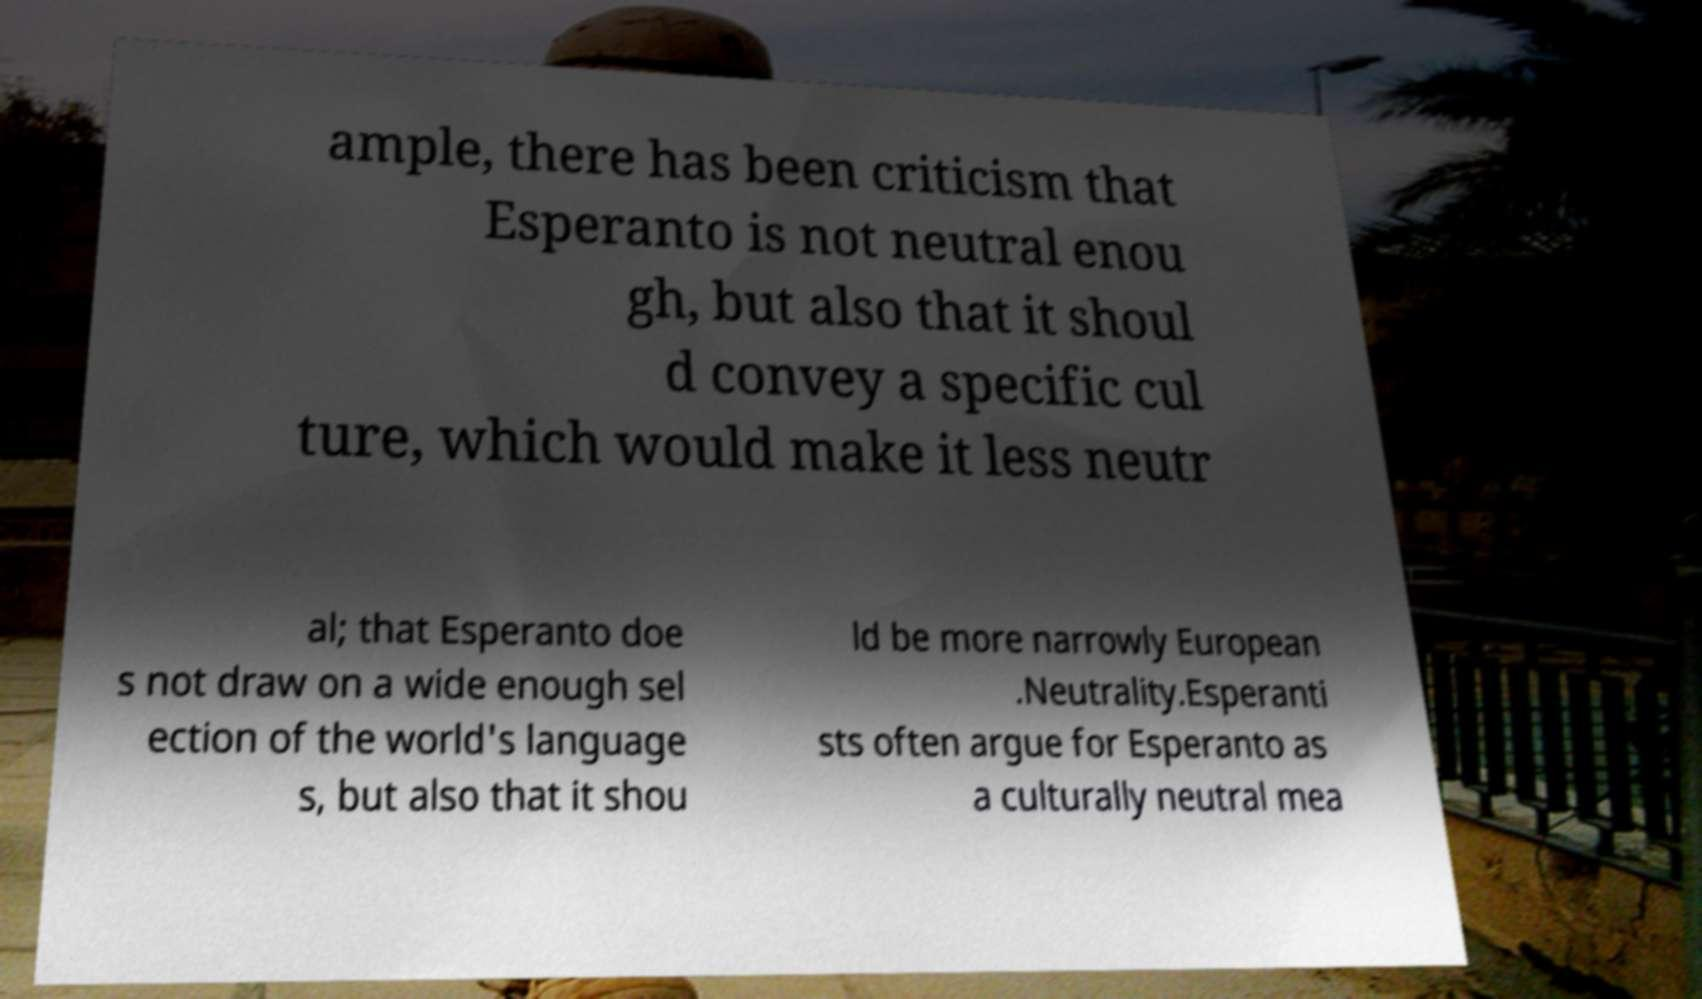There's text embedded in this image that I need extracted. Can you transcribe it verbatim? ample, there has been criticism that Esperanto is not neutral enou gh, but also that it shoul d convey a specific cul ture, which would make it less neutr al; that Esperanto doe s not draw on a wide enough sel ection of the world's language s, but also that it shou ld be more narrowly European .Neutrality.Esperanti sts often argue for Esperanto as a culturally neutral mea 